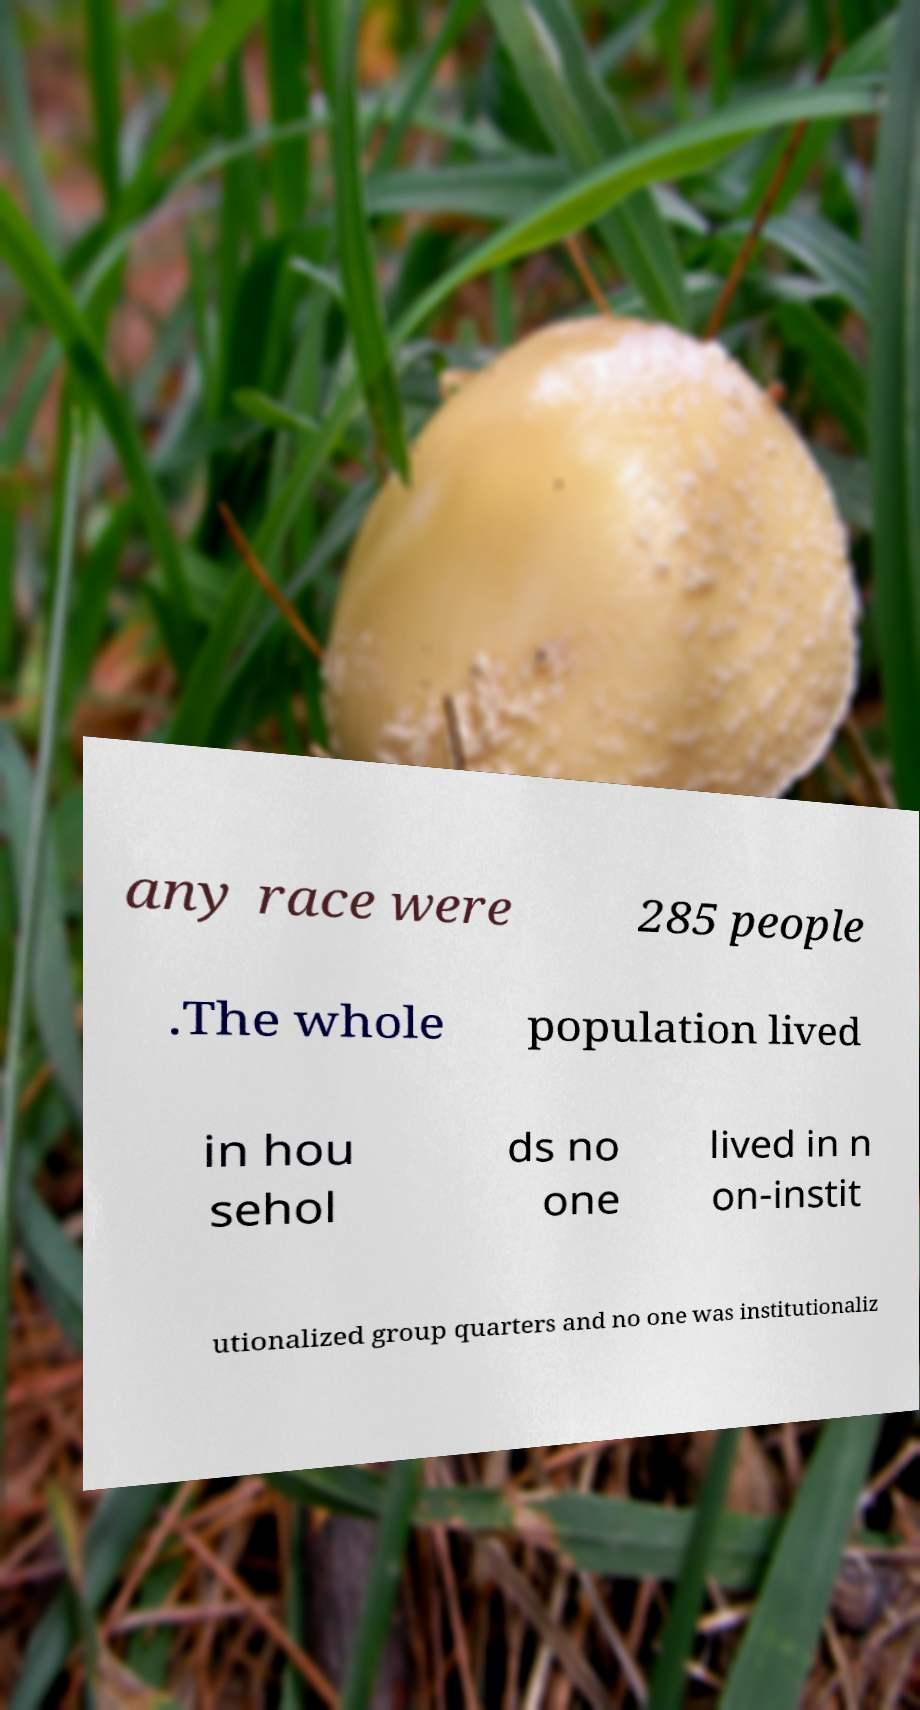Can you read and provide the text displayed in the image?This photo seems to have some interesting text. Can you extract and type it out for me? any race were 285 people .The whole population lived in hou sehol ds no one lived in n on-instit utionalized group quarters and no one was institutionaliz 